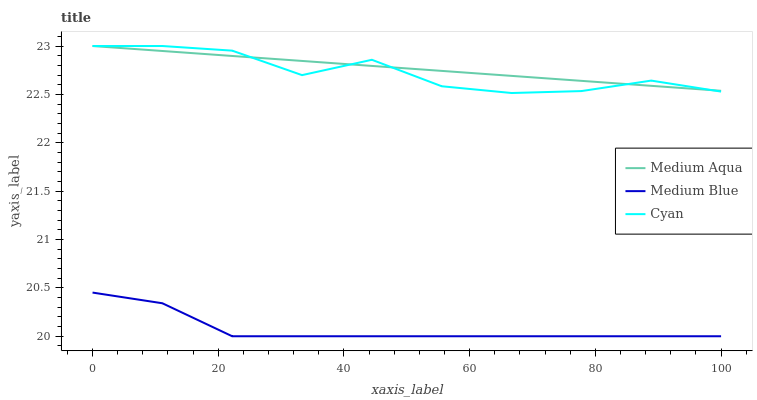Does Medium Blue have the minimum area under the curve?
Answer yes or no. Yes. Does Medium Aqua have the maximum area under the curve?
Answer yes or no. Yes. Does Cyan have the minimum area under the curve?
Answer yes or no. No. Does Cyan have the maximum area under the curve?
Answer yes or no. No. Is Medium Aqua the smoothest?
Answer yes or no. Yes. Is Cyan the roughest?
Answer yes or no. Yes. Is Cyan the smoothest?
Answer yes or no. No. Is Medium Aqua the roughest?
Answer yes or no. No. Does Medium Blue have the lowest value?
Answer yes or no. Yes. Does Cyan have the lowest value?
Answer yes or no. No. Does Cyan have the highest value?
Answer yes or no. Yes. Is Medium Blue less than Medium Aqua?
Answer yes or no. Yes. Is Cyan greater than Medium Blue?
Answer yes or no. Yes. Does Medium Aqua intersect Cyan?
Answer yes or no. Yes. Is Medium Aqua less than Cyan?
Answer yes or no. No. Is Medium Aqua greater than Cyan?
Answer yes or no. No. Does Medium Blue intersect Medium Aqua?
Answer yes or no. No. 